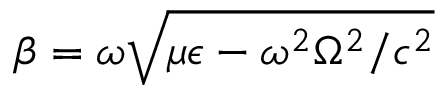<formula> <loc_0><loc_0><loc_500><loc_500>\beta = \omega \sqrt { \mu \epsilon - \omega ^ { 2 } \Omega ^ { 2 } / c ^ { 2 } }</formula> 